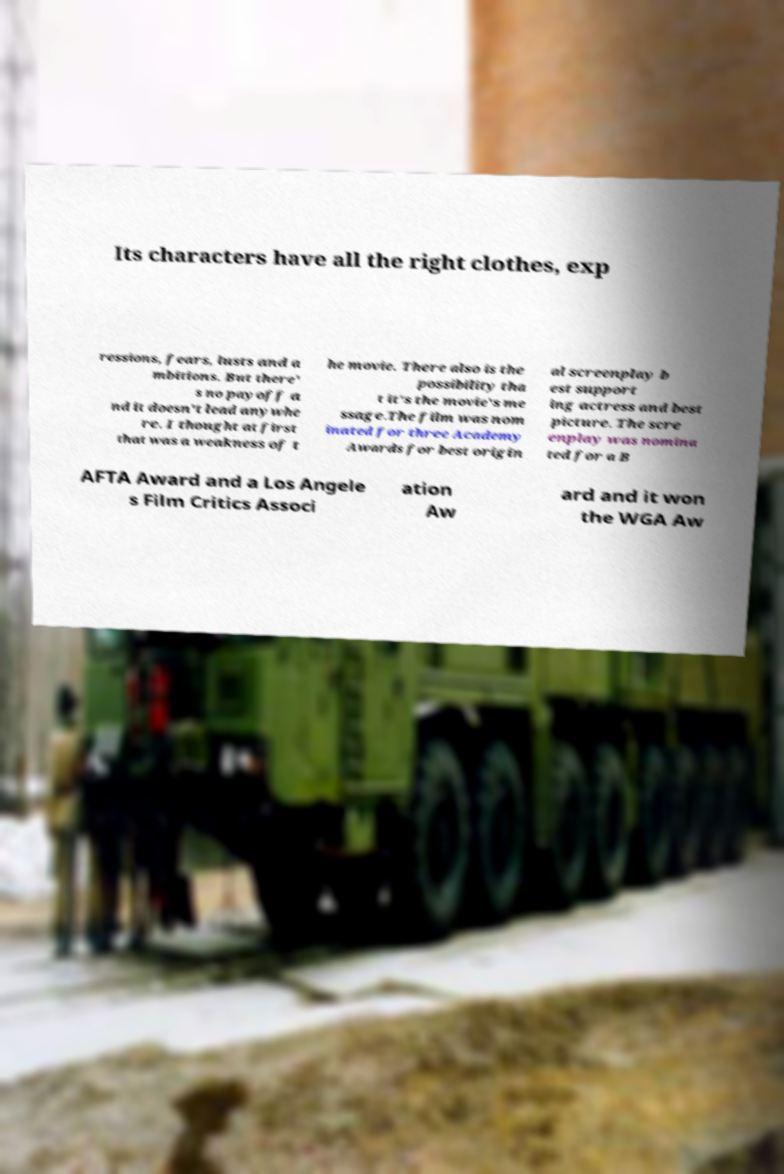Could you assist in decoding the text presented in this image and type it out clearly? Its characters have all the right clothes, exp ressions, fears, lusts and a mbitions. But there' s no payoff a nd it doesn't lead anywhe re. I thought at first that was a weakness of t he movie. There also is the possibility tha t it's the movie's me ssage.The film was nom inated for three Academy Awards for best origin al screenplay b est support ing actress and best picture. The scre enplay was nomina ted for a B AFTA Award and a Los Angele s Film Critics Associ ation Aw ard and it won the WGA Aw 